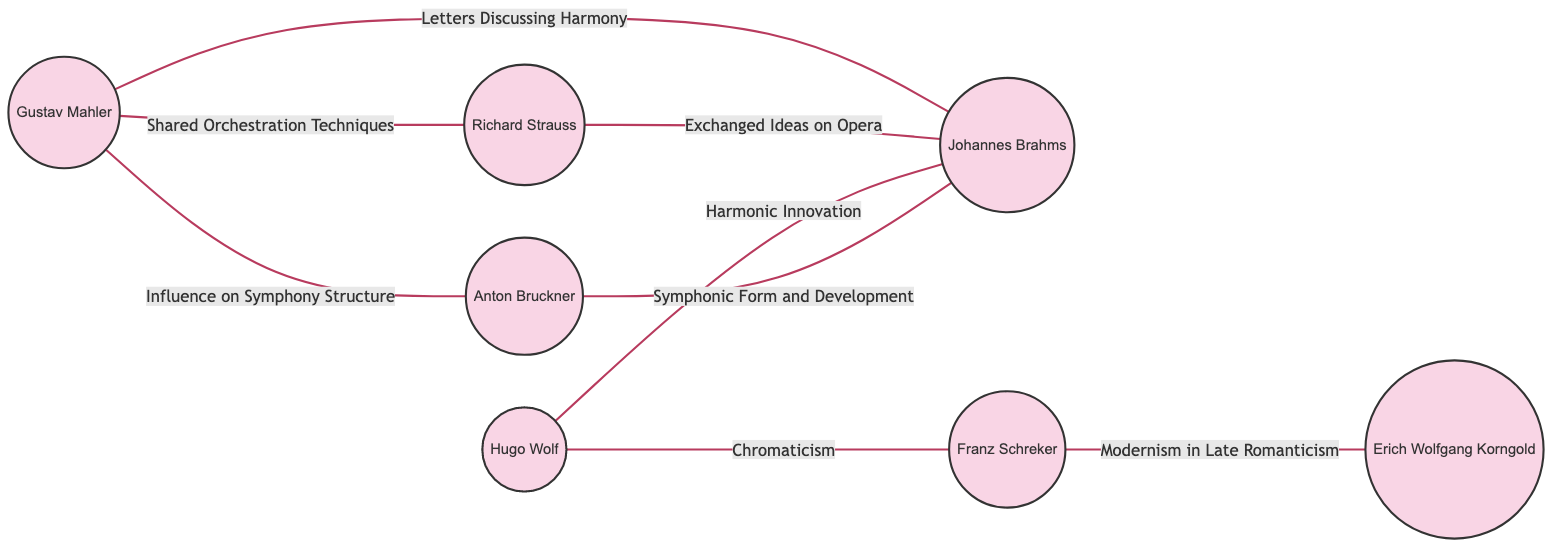What is the total number of composers represented in the diagram? The diagram lists 7 nodes, each representing a composer: Gustav Mahler, Richard Strauss, Anton Bruckner, Hugo Wolf, Johannes Brahms, Franz Schreker, and Erich Wolfgang Korngold. Therefore, the total number of composers is 7.
Answer: 7 Which two composers are connected by the edge labeled "Shared Orchestration Techniques"? The edge labeled "Shared Orchestration Techniques" connects Gustav Mahler and Richard Strauss, as indicated by their respective nodes and the connection label on the diagram.
Answer: Gustav Mahler and Richard Strauss What is the relationship between Anton Bruckner and Johannes Brahms as depicted in the diagram? The relationship between Anton Bruckner and Johannes Brahms is defined by the edge labeled "Symphonic Form and Development," which indicates their correspondence and influence on each other concerning thematic development in symphonic works.
Answer: Symphonic Form and Development How many unique connections emerge from Johannes Brahms in the diagram? Johannes Brahms has three outgoing connections to Gustav Mahler, Richard Strauss, and Hugo Wolf, as represented by the edges leading from his node to these composers. Therefore, the number of unique connections is 3.
Answer: 3 Which composer directly influences Franz Schreker according to the diagram? According to the diagram, the composer that directly influences Franz Schreker is Hugo Wolf, indicated by the edge labeled "Chromaticism," which connects them, showing an exchange of techniques related to chromatic harmony.
Answer: Hugo Wolf What is the main topic of correspondence between Richard Strauss and Johannes Brahms? The main topic of correspondence between Richard Strauss and Johannes Brahms is described by the edge labeled "Exchanged Ideas on Opera," indicating that their discussion pertained to operatic themes and techniques.
Answer: Exchanged Ideas on Opera Identify the composer linked to the edge labeled "Modernism in Late Romanticism." The edge labeled "Modernism in Late Romanticism" connects Franz Schreker with Erich Wolfgang Korngold, which signifies Schreker's influence on Korngold's modernist tendencies in the context of late romantic music.
Answer: Erich Wolfgang Korngold Which two composers are connected through the "Harmonic Innovation" edge? The edge labeled "Harmonic Innovation" connects Hugo Wolf and Johannes Brahms, indicating a shared exploration of innovative harmonic practices in their compositions.
Answer: Hugo Wolf and Johannes Brahms 